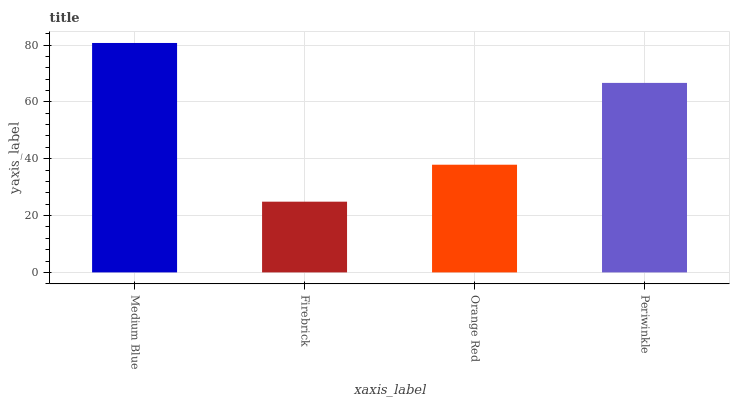Is Orange Red the minimum?
Answer yes or no. No. Is Orange Red the maximum?
Answer yes or no. No. Is Orange Red greater than Firebrick?
Answer yes or no. Yes. Is Firebrick less than Orange Red?
Answer yes or no. Yes. Is Firebrick greater than Orange Red?
Answer yes or no. No. Is Orange Red less than Firebrick?
Answer yes or no. No. Is Periwinkle the high median?
Answer yes or no. Yes. Is Orange Red the low median?
Answer yes or no. Yes. Is Firebrick the high median?
Answer yes or no. No. Is Periwinkle the low median?
Answer yes or no. No. 